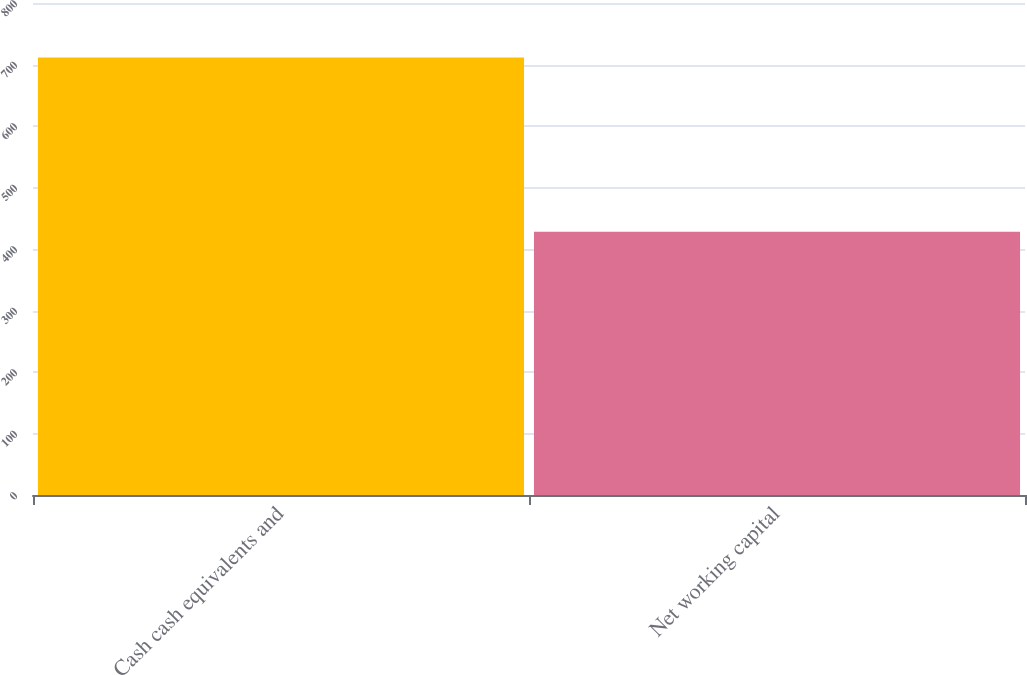Convert chart to OTSL. <chart><loc_0><loc_0><loc_500><loc_500><bar_chart><fcel>Cash cash equivalents and<fcel>Net working capital<nl><fcel>711.2<fcel>427.9<nl></chart> 